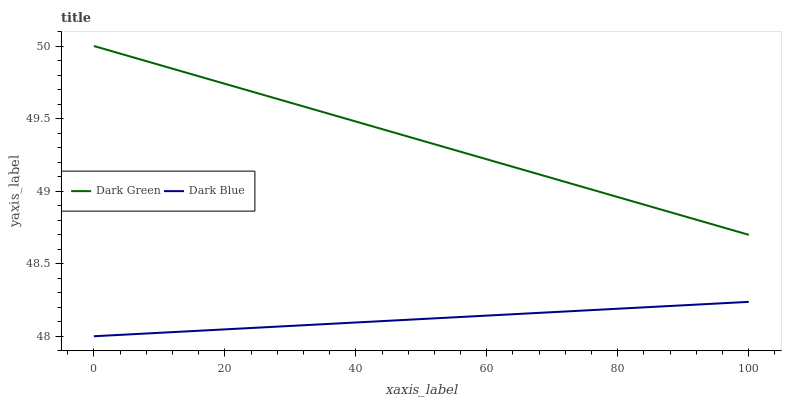Does Dark Green have the minimum area under the curve?
Answer yes or no. No. Is Dark Green the smoothest?
Answer yes or no. No. Does Dark Green have the lowest value?
Answer yes or no. No. Is Dark Blue less than Dark Green?
Answer yes or no. Yes. Is Dark Green greater than Dark Blue?
Answer yes or no. Yes. Does Dark Blue intersect Dark Green?
Answer yes or no. No. 